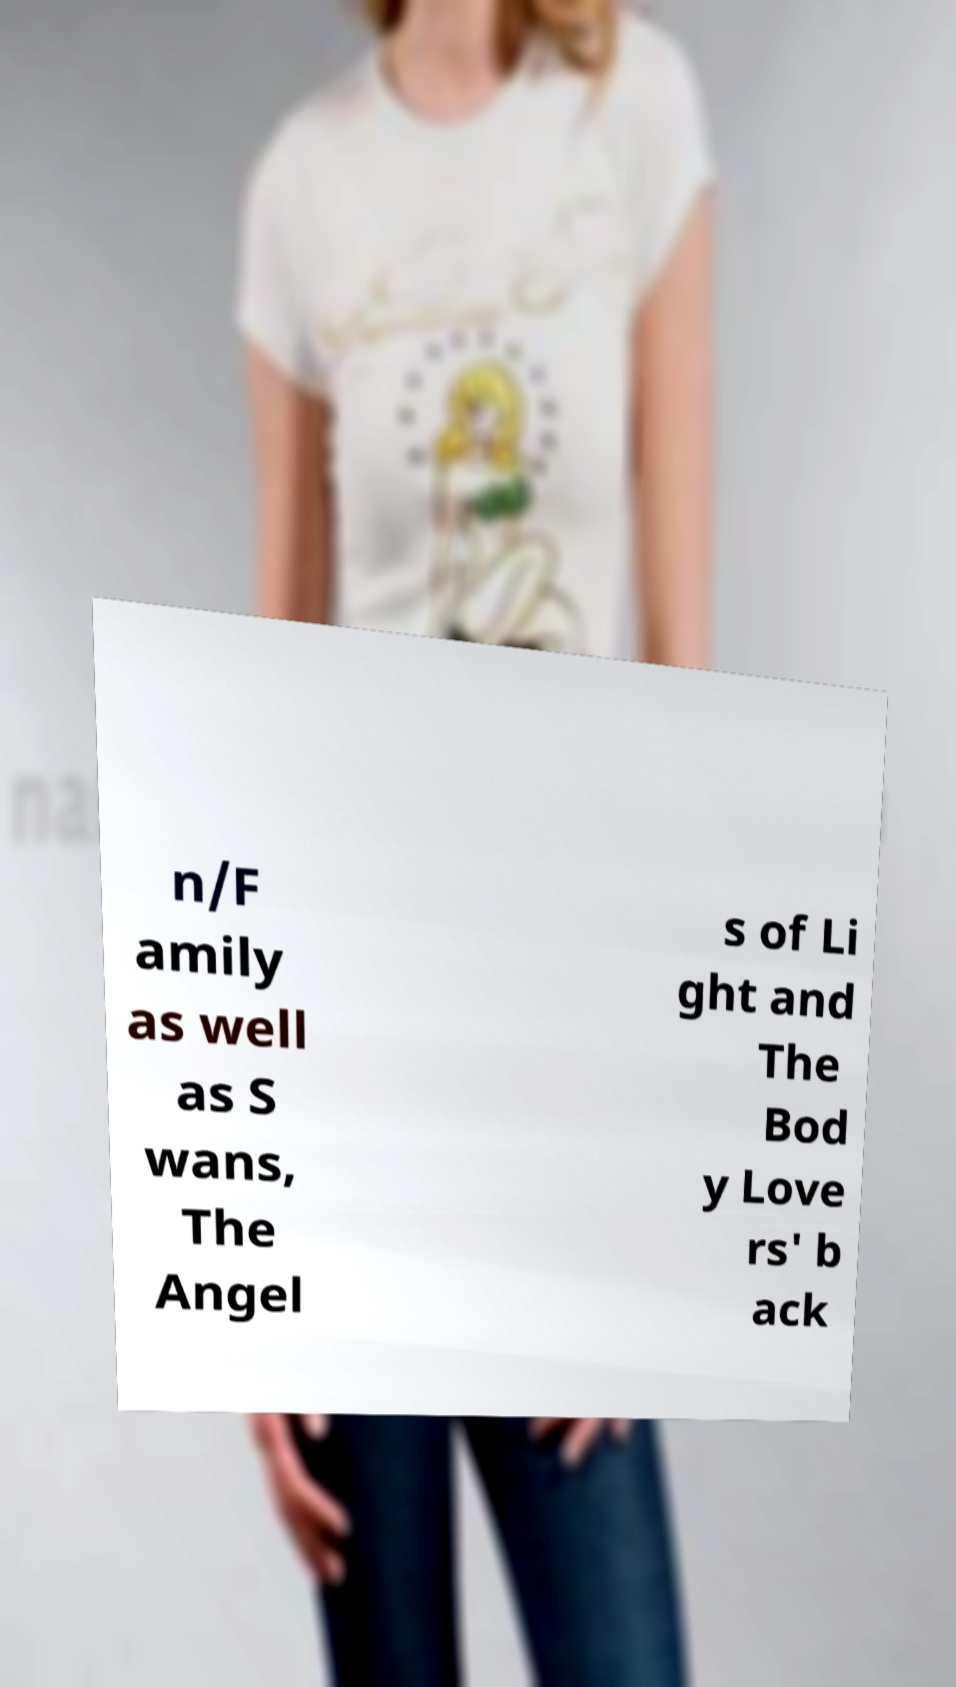For documentation purposes, I need the text within this image transcribed. Could you provide that? n/F amily as well as S wans, The Angel s of Li ght and The Bod y Love rs' b ack 